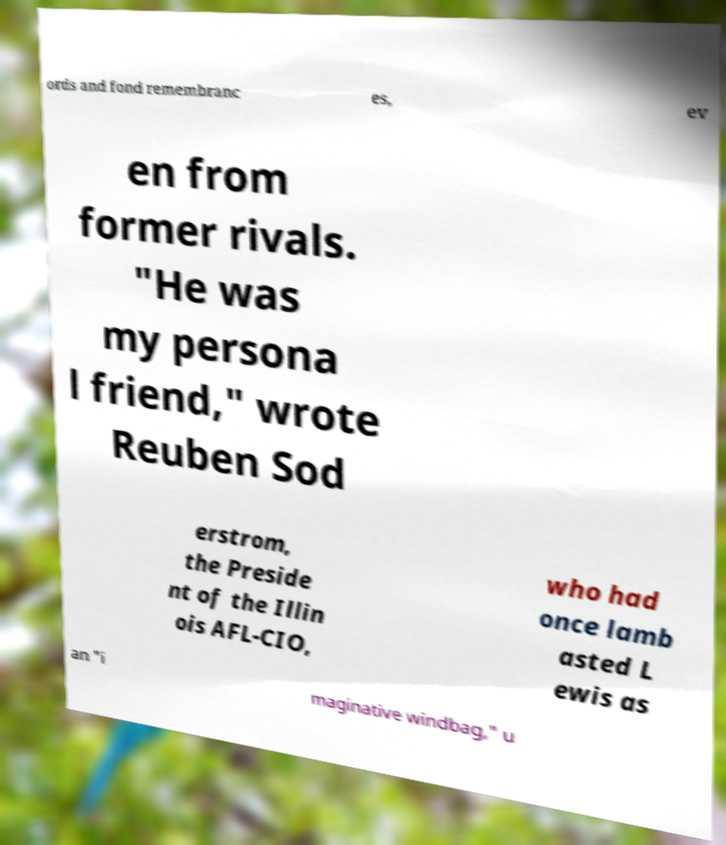Can you accurately transcribe the text from the provided image for me? ords and fond remembranc es, ev en from former rivals. "He was my persona l friend," wrote Reuben Sod erstrom, the Preside nt of the Illin ois AFL-CIO, who had once lamb asted L ewis as an "i maginative windbag," u 